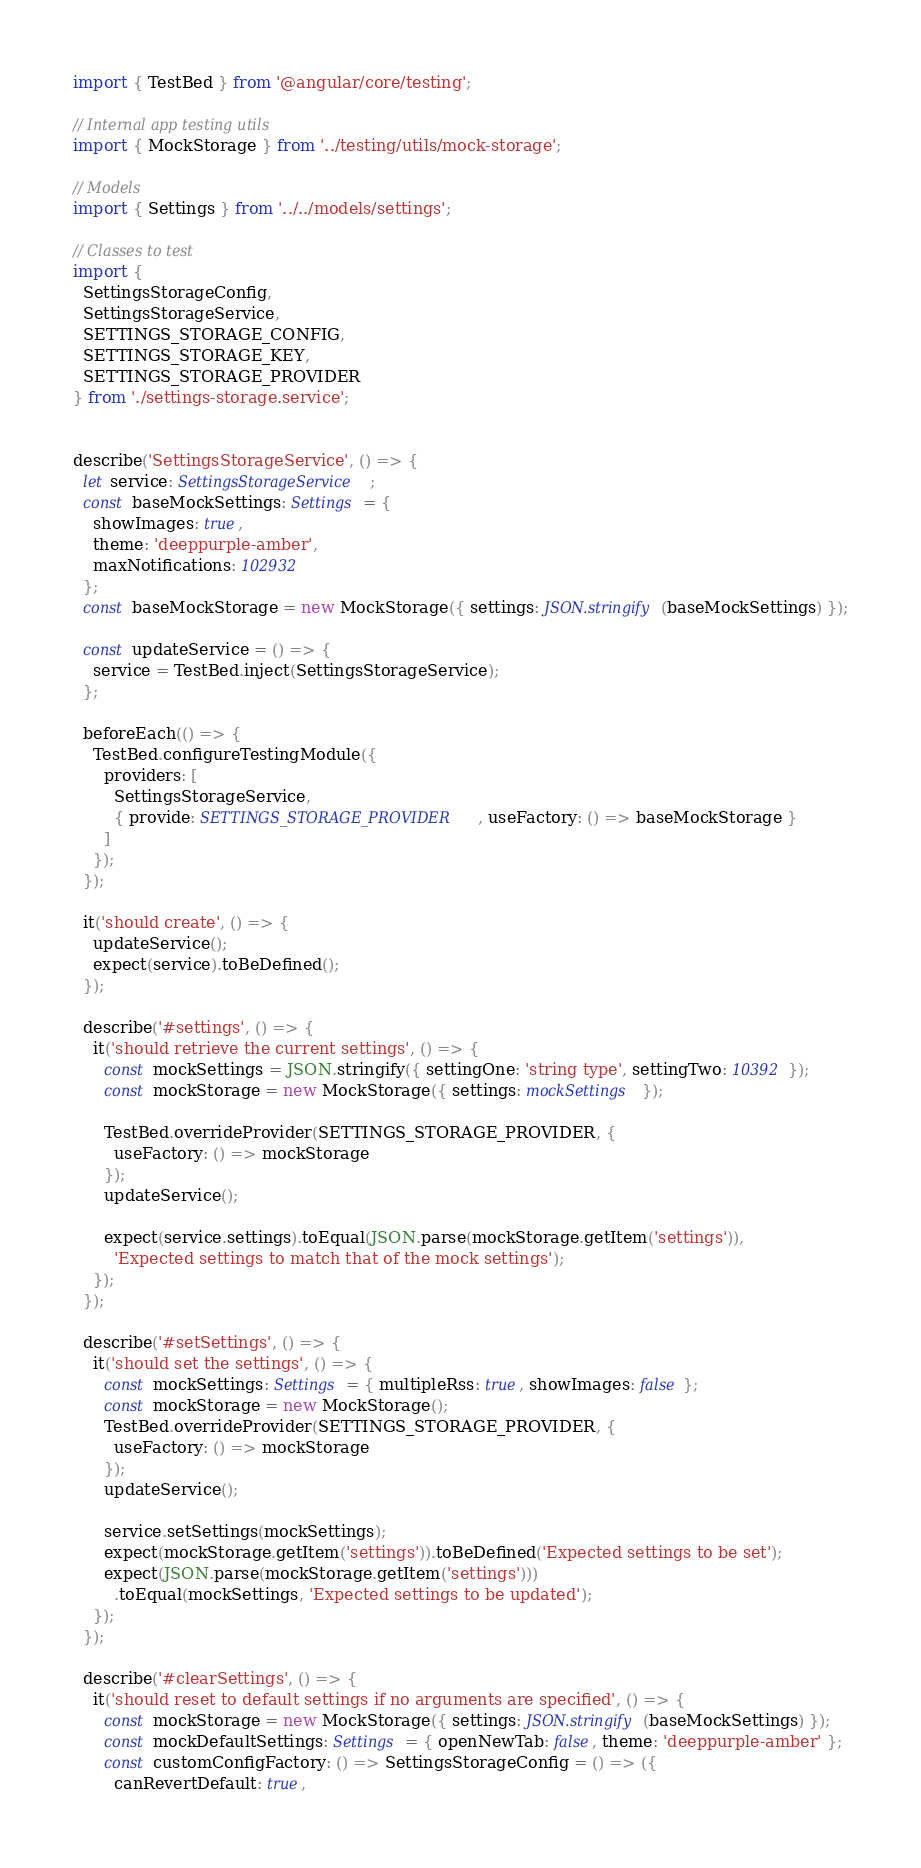Convert code to text. <code><loc_0><loc_0><loc_500><loc_500><_TypeScript_>import { TestBed } from '@angular/core/testing';

// Internal app testing utils
import { MockStorage } from '../testing/utils/mock-storage';

// Models
import { Settings } from '../../models/settings';

// Classes to test
import {
  SettingsStorageConfig,
  SettingsStorageService,
  SETTINGS_STORAGE_CONFIG,
  SETTINGS_STORAGE_KEY,
  SETTINGS_STORAGE_PROVIDER
} from './settings-storage.service';


describe('SettingsStorageService', () => {
  let service: SettingsStorageService;
  const baseMockSettings: Settings = {
    showImages: true,
    theme: 'deeppurple-amber',
    maxNotifications: 102932
  };
  const baseMockStorage = new MockStorage({ settings: JSON.stringify(baseMockSettings) });

  const updateService = () => {
    service = TestBed.inject(SettingsStorageService);
  };

  beforeEach(() => {
    TestBed.configureTestingModule({
      providers: [
        SettingsStorageService,
        { provide: SETTINGS_STORAGE_PROVIDER, useFactory: () => baseMockStorage }
      ]
    });
  });

  it('should create', () => {
    updateService();
    expect(service).toBeDefined();
  });

  describe('#settings', () => {
    it('should retrieve the current settings', () => {
      const mockSettings = JSON.stringify({ settingOne: 'string type', settingTwo: 10392 });
      const mockStorage = new MockStorage({ settings: mockSettings });

      TestBed.overrideProvider(SETTINGS_STORAGE_PROVIDER, {
        useFactory: () => mockStorage
      });
      updateService();

      expect(service.settings).toEqual(JSON.parse(mockStorage.getItem('settings')),
        'Expected settings to match that of the mock settings');
    });
  });

  describe('#setSettings', () => {
    it('should set the settings', () => {
      const mockSettings: Settings = { multipleRss: true, showImages: false };
      const mockStorage = new MockStorage();
      TestBed.overrideProvider(SETTINGS_STORAGE_PROVIDER, {
        useFactory: () => mockStorage
      });
      updateService();

      service.setSettings(mockSettings);
      expect(mockStorage.getItem('settings')).toBeDefined('Expected settings to be set');
      expect(JSON.parse(mockStorage.getItem('settings')))
        .toEqual(mockSettings, 'Expected settings to be updated');
    });
  });

  describe('#clearSettings', () => {
    it('should reset to default settings if no arguments are specified', () => {
      const mockStorage = new MockStorage({ settings: JSON.stringify(baseMockSettings) });
      const mockDefaultSettings: Settings = { openNewTab: false, theme: 'deeppurple-amber' };
      const customConfigFactory: () => SettingsStorageConfig = () => ({
        canRevertDefault: true,</code> 